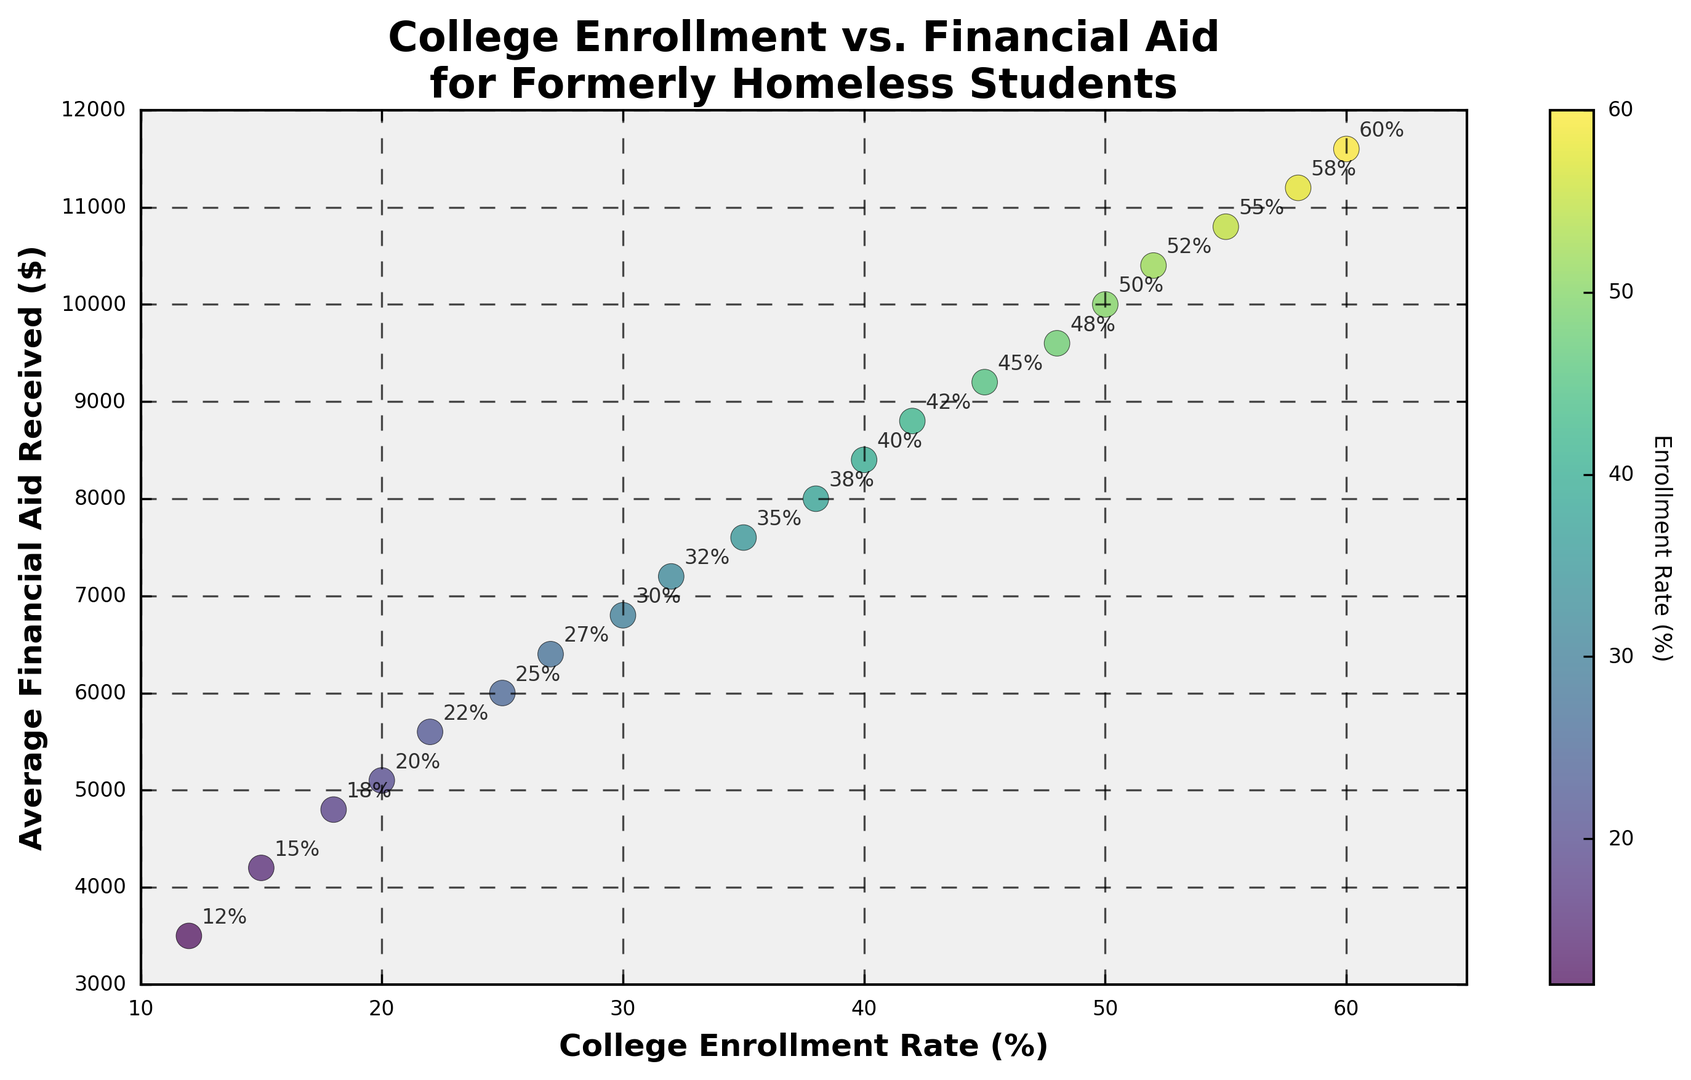What is the average financial aid received at a college enrollment rate of 40%? Locate the point on the scatter plot corresponding to a 40% college enrollment rate. The corresponding financial aid amount is $8,400.
Answer: $8,400 How does the financial aid received at a 15% enrollment rate compare to that of a 30% enrollment rate? Find and compare the financial aid amounts for the two enrollment rates: $4,200 at 15% and $6,800 at 30%. The financial aid increases from $4,200 to $6,800.
Answer: Increases Which enrollment rate corresponds to the highest average financial aid received? Identify the point on the scatter plot with the highest value on the financial aid axis. The highest point is $11,600, corresponding to a 60% enrollment rate.
Answer: 60% What is the enrollment rate when the average financial aid received is $7,600? Locate the point on the scatter plot with a financial aid value of $7,600. The corresponding enrollment rate is 35%.
Answer: 35% Is there a positive or negative trend between college enrollment rate and average financial aid received? Observe how the points are distributed on the scatter plot. Points move upward and to the right as enrollment rate increases. This indicates a positive trend.
Answer: Positive What is the range of financial aid values present in the plot? Identify the minimum and maximum financial aid values. The minimum is $3,500 and the maximum is $11,600. The range is $11,600 - $3,500.
Answer: $8,100 How many enrollment rates have financial aid amounts exceeding $9,000? Count the number of points above the $9,000 financial aid line. There are 6 points exceeding $9,000.
Answer: 6 What color represents an enrollment rate of 12% on the scatter plot? Look at the color bar to find the color corresponding to 12%. The color for lower enrollment rates like 12% is near the start of the color bar, which is green.
Answer: Green 